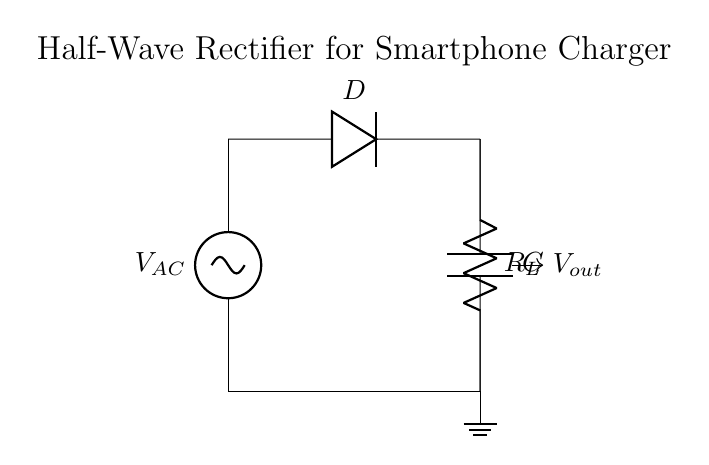What is the type of rectifier used in this circuit? The circuit specifically shows a half-wave rectifier, which allows only one half of the AC waveform to pass while blocking the other half using a diode.
Answer: half-wave rectifier Which component is responsible for allowing current to flow in one direction? The diode (labeled D) is the component that permits current flow in only one direction, preventing the reverse current which would occur during the opposite half-cycle of the AC input.
Answer: diode What is the function of the capacitor in this circuit? The capacitor (labeled C) is used to smooth the output voltage by charging during the conductive half-cycle and discharging to maintain the voltage level during the non-conductive portion of the AC cycle.
Answer: smoothing How does the output voltage relate to the AC input voltage? The output voltage (labeled Vout) is approximately the peak voltage of the AC input minus the forward voltage drop of the diode when it's conducting; thus it will be lower than the peak AC input voltage.
Answer: peak minus voltage drop What happens to the output voltage when the load resistor is removed? When the load resistor (labeled R_L) is removed, there will be no current flow in the circuit; hence, the capacitor will charge to the peak voltage but will not discharge through any load, potentially leading to a maximum voltage across the capacitor with no current being delivered.
Answer: maximum voltage What will be the effect of increasing the load resistance on the output voltage? Increasing the load resistance will reduce the output current; thus, the output voltage will remain closer to the peak voltage, assuming the capacitor can hold the charge during the intervals when the diode is off.
Answer: higher voltage What is the relationship between the diode orientation and its operation in this rectifier? The diode must be oriented in a way that allows current to flow towards the load and capacitor during the positive half-cycle of the AC signal. If reversed, it will block current and prevent the circuit from functioning properly.
Answer: correct orientation 